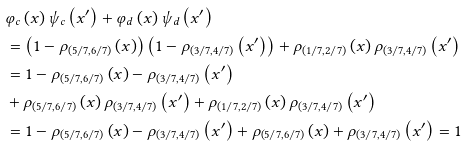Convert formula to latex. <formula><loc_0><loc_0><loc_500><loc_500>& \varphi _ { c } \left ( x \right ) \psi _ { c } \left ( x ^ { \prime } \right ) + \varphi _ { d } \left ( x \right ) \psi _ { d } \left ( x ^ { \prime } \right ) \\ & = \left ( 1 - \rho _ { \left ( 5 / 7 , 6 / 7 \right ) } \left ( x \right ) \right ) \left ( 1 - \rho _ { \left ( 3 / 7 , 4 / 7 \right ) } \left ( x ^ { \prime } \right ) \right ) + \rho _ { \left ( 1 / 7 , 2 / 7 \right ) } \left ( x \right ) \rho _ { \left ( 3 / 7 , 4 / 7 \right ) } \left ( x ^ { \prime } \right ) \\ & = 1 - \rho _ { \left ( 5 / 7 , 6 / 7 \right ) } \left ( x \right ) - \rho _ { \left ( 3 / 7 , 4 / 7 \right ) } \left ( x ^ { \prime } \right ) \\ & + \rho _ { \left ( 5 / 7 , 6 / 7 \right ) } \left ( x \right ) \rho _ { \left ( 3 / 7 , 4 / 7 \right ) } \left ( x ^ { \prime } \right ) + \rho _ { \left ( 1 / 7 , 2 / 7 \right ) } \left ( x \right ) \rho _ { \left ( 3 / 7 , 4 / 7 \right ) } \left ( x ^ { \prime } \right ) \\ & = 1 - \rho _ { \left ( 5 / 7 , 6 / 7 \right ) } \left ( x \right ) - \rho _ { \left ( 3 / 7 , 4 / 7 \right ) } \left ( x ^ { \prime } \right ) + \rho _ { \left ( 5 / 7 , 6 / 7 \right ) } \left ( x \right ) + \rho _ { \left ( 3 / 7 , 4 / 7 \right ) } \left ( x ^ { \prime } \right ) = 1</formula> 